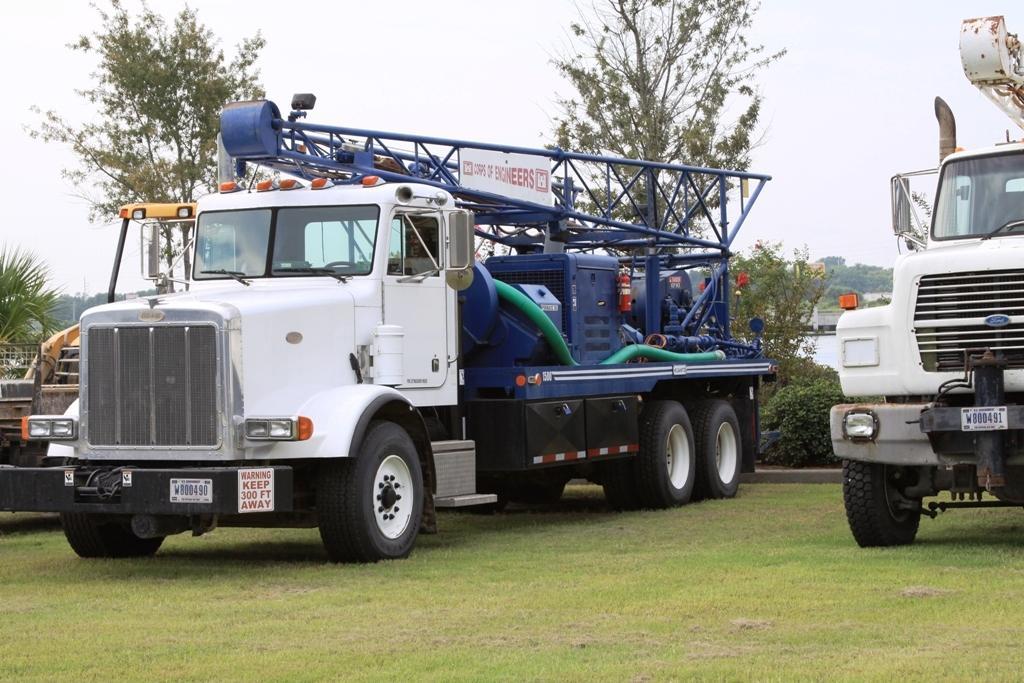Could you give a brief overview of what you see in this image? This picture is clicked outside. In the center we can see the vehicles parked on the ground and we can see the green grass, plants, trees. In the background we can see the sky and some other items and we can see the metal rods. 